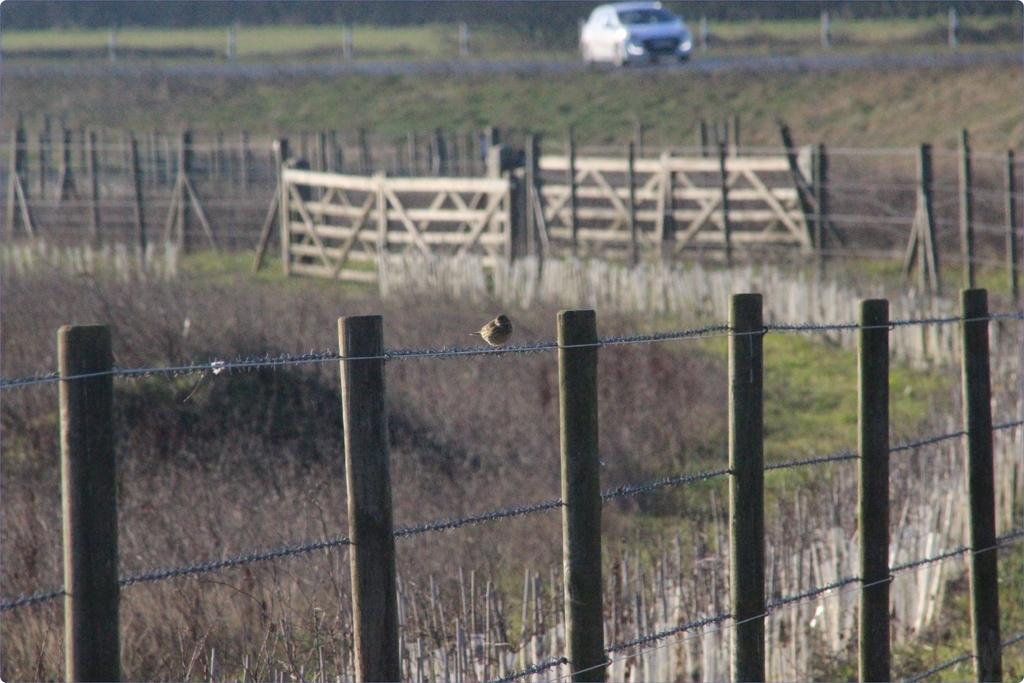Can you describe this image briefly? In this image we can see fences. At the bottom there is grass. In the background we can see a car on the road. 